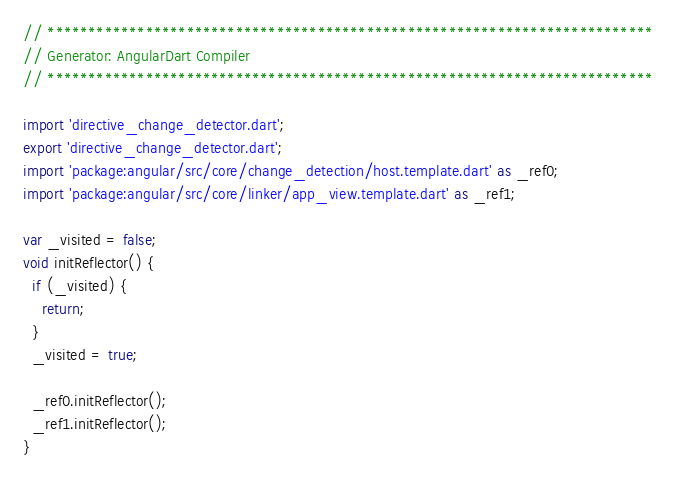Convert code to text. <code><loc_0><loc_0><loc_500><loc_500><_Dart_>// **************************************************************************
// Generator: AngularDart Compiler
// **************************************************************************

import 'directive_change_detector.dart';
export 'directive_change_detector.dart';
import 'package:angular/src/core/change_detection/host.template.dart' as _ref0;
import 'package:angular/src/core/linker/app_view.template.dart' as _ref1;

var _visited = false;
void initReflector() {
  if (_visited) {
    return;
  }
  _visited = true;

  _ref0.initReflector();
  _ref1.initReflector();
}
</code> 